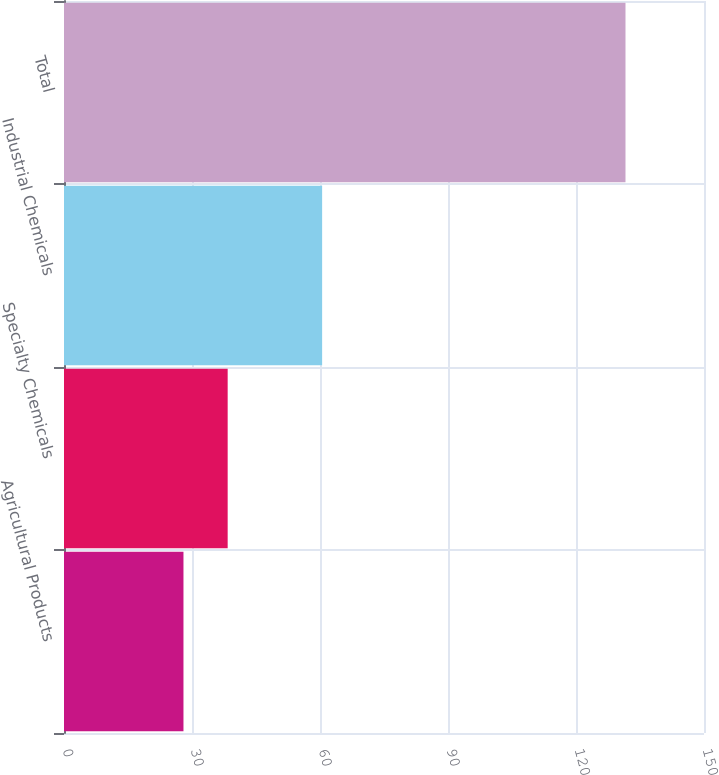Convert chart to OTSL. <chart><loc_0><loc_0><loc_500><loc_500><bar_chart><fcel>Agricultural Products<fcel>Specialty Chemicals<fcel>Industrial Chemicals<fcel>Total<nl><fcel>28<fcel>38.36<fcel>60.5<fcel>131.6<nl></chart> 